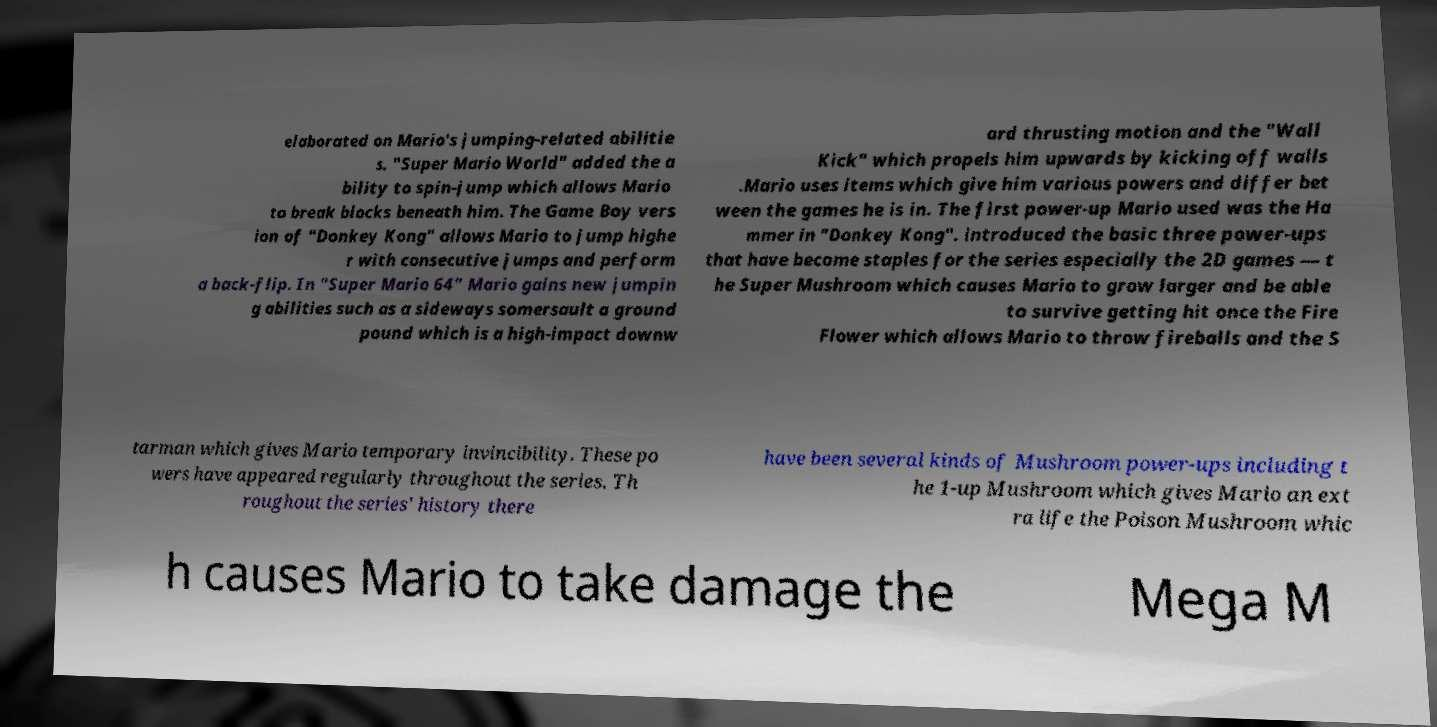What messages or text are displayed in this image? I need them in a readable, typed format. elaborated on Mario's jumping-related abilitie s. "Super Mario World" added the a bility to spin-jump which allows Mario to break blocks beneath him. The Game Boy vers ion of "Donkey Kong" allows Mario to jump highe r with consecutive jumps and perform a back-flip. In "Super Mario 64" Mario gains new jumpin g abilities such as a sideways somersault a ground pound which is a high-impact downw ard thrusting motion and the "Wall Kick" which propels him upwards by kicking off walls .Mario uses items which give him various powers and differ bet ween the games he is in. The first power-up Mario used was the Ha mmer in "Donkey Kong". introduced the basic three power-ups that have become staples for the series especially the 2D games — t he Super Mushroom which causes Mario to grow larger and be able to survive getting hit once the Fire Flower which allows Mario to throw fireballs and the S tarman which gives Mario temporary invincibility. These po wers have appeared regularly throughout the series. Th roughout the series' history there have been several kinds of Mushroom power-ups including t he 1-up Mushroom which gives Mario an ext ra life the Poison Mushroom whic h causes Mario to take damage the Mega M 